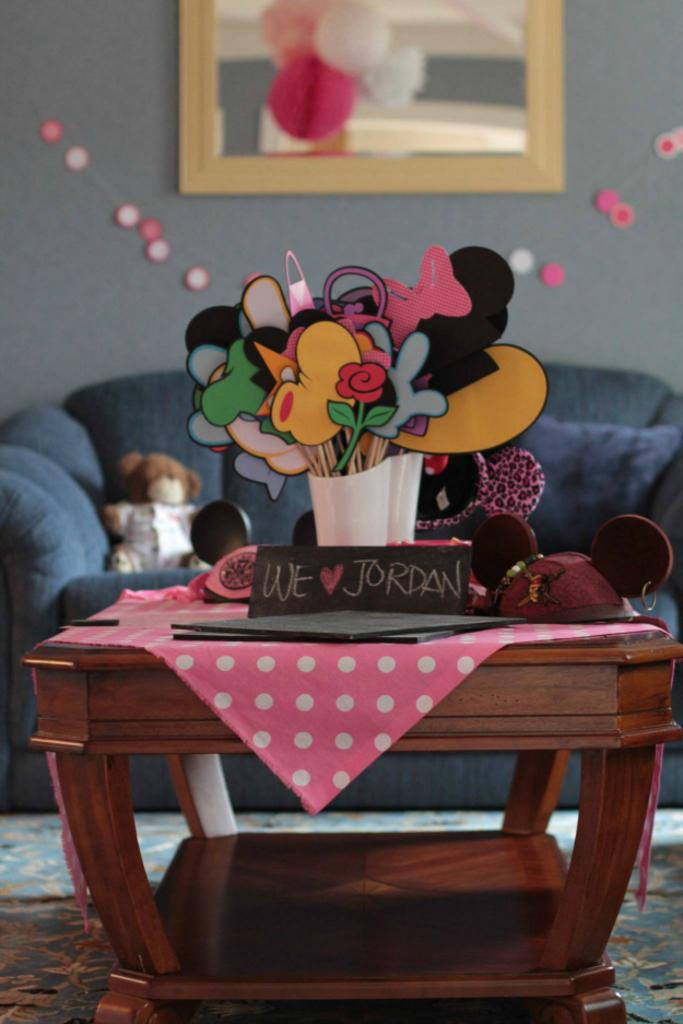What type of furniture is present in the image? There is a table in the image. What is covering the table? There is a cloth on the table. What can be seen in the background of the image? There is a couch and a wall in the background of the image. What is hanging on the wall? There is a portrait on the wall. What type of decoration is on the table? There are flowers on the table. What year is depicted in the portrait on the wall? There is no indication of a specific year in the portrait on the wall. Can you see a window in the image? There is no mention of a window in the provided facts, so it cannot be determined if one is present in the image. 